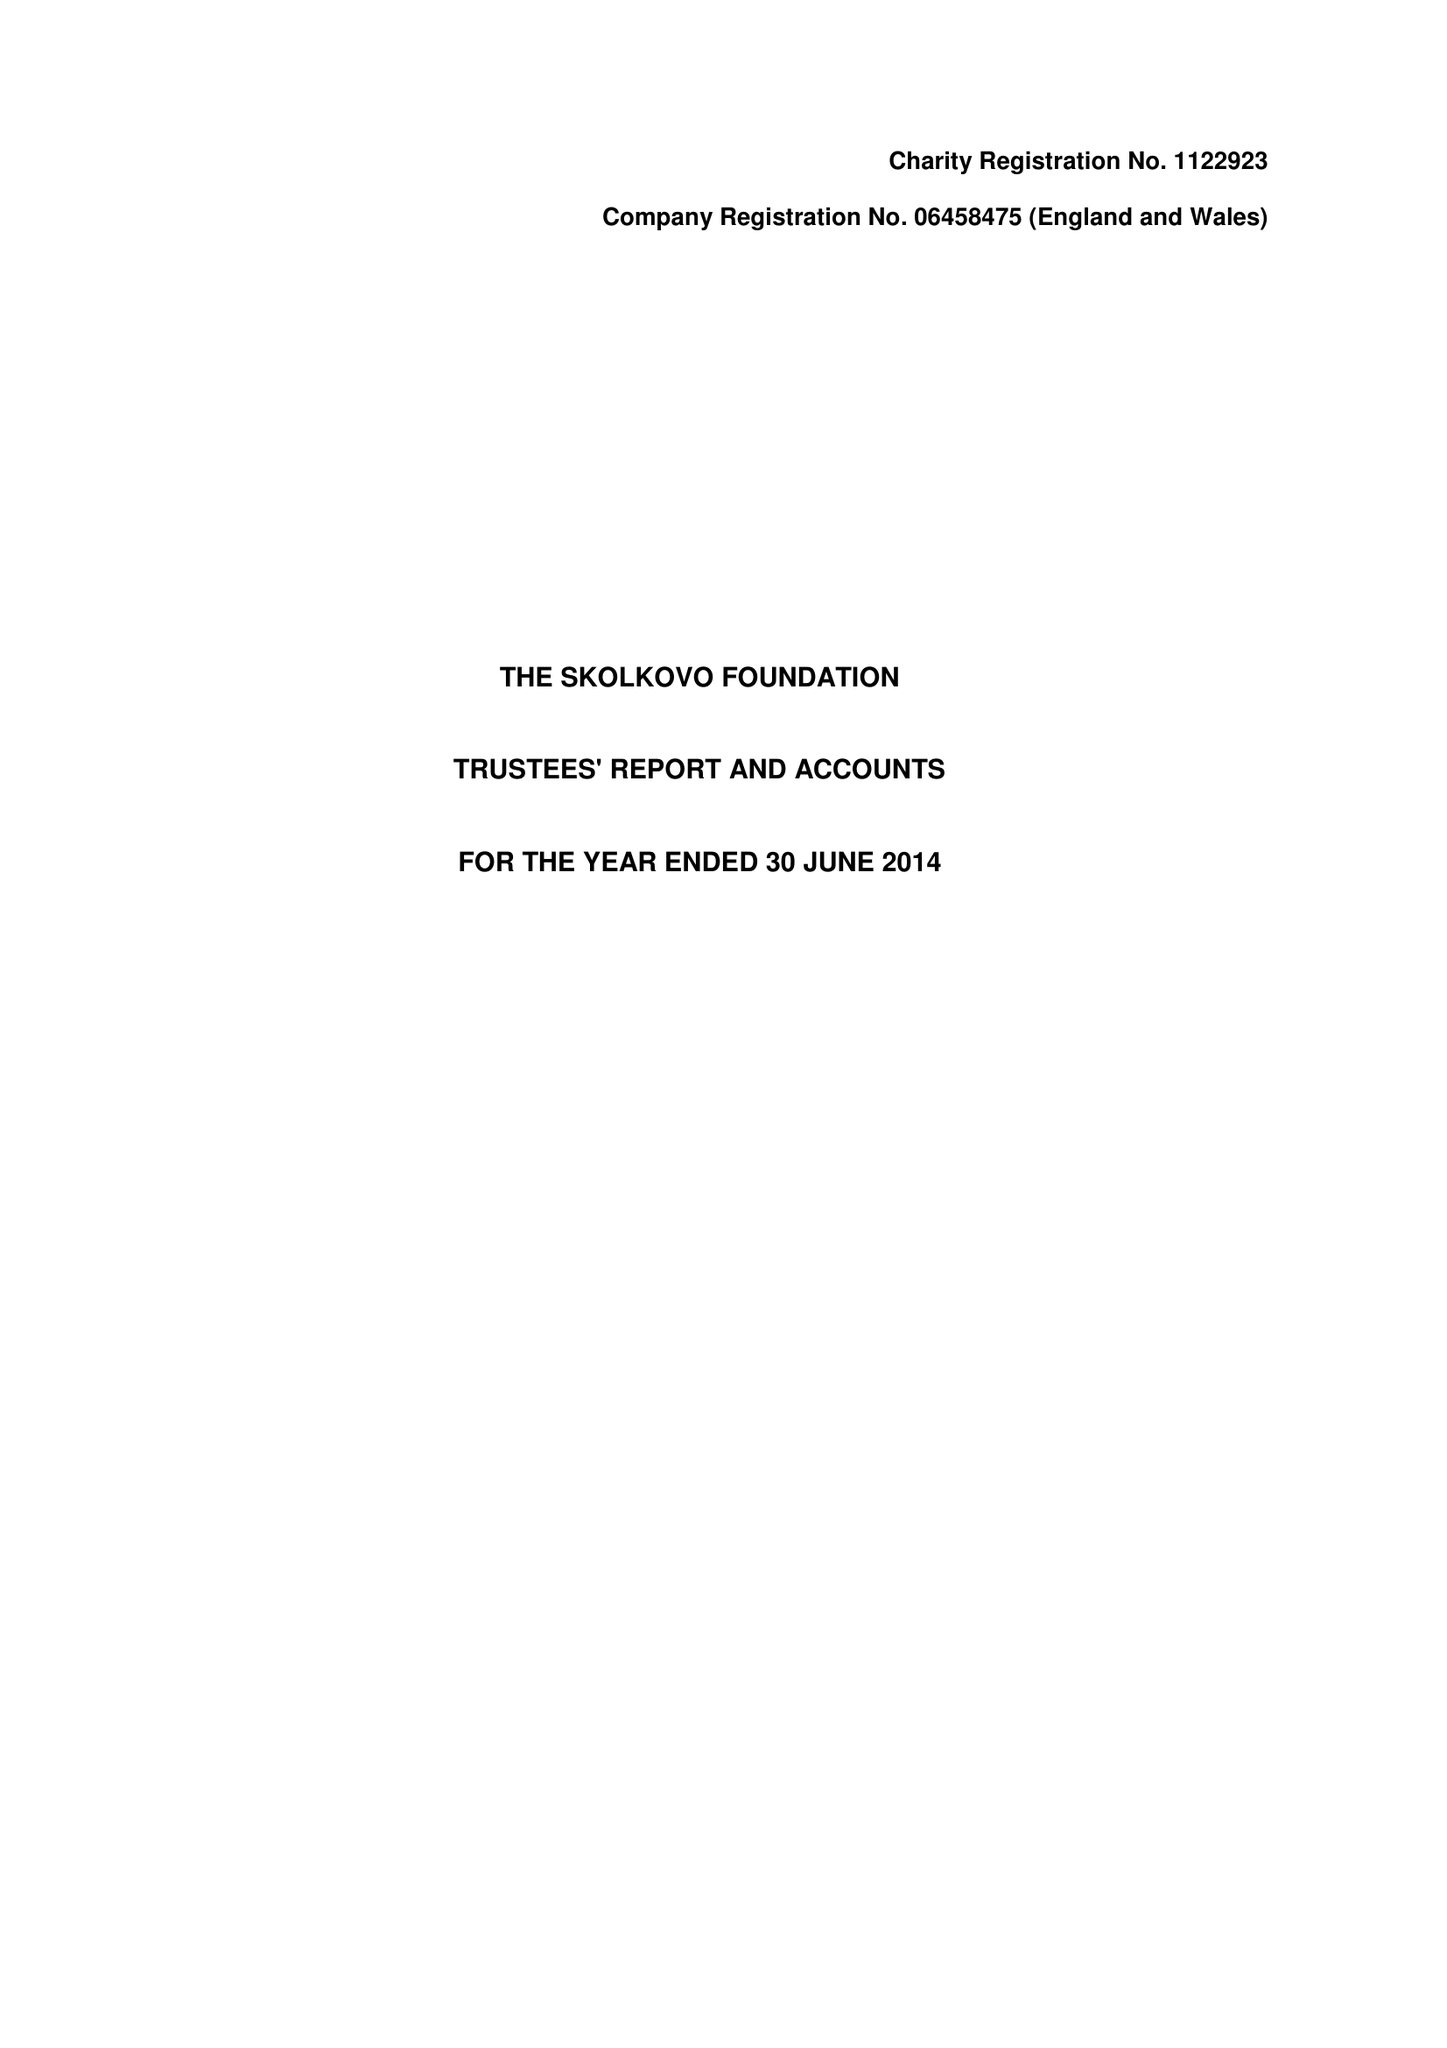What is the value for the address__postcode?
Answer the question using a single word or phrase. ME19 4TA 